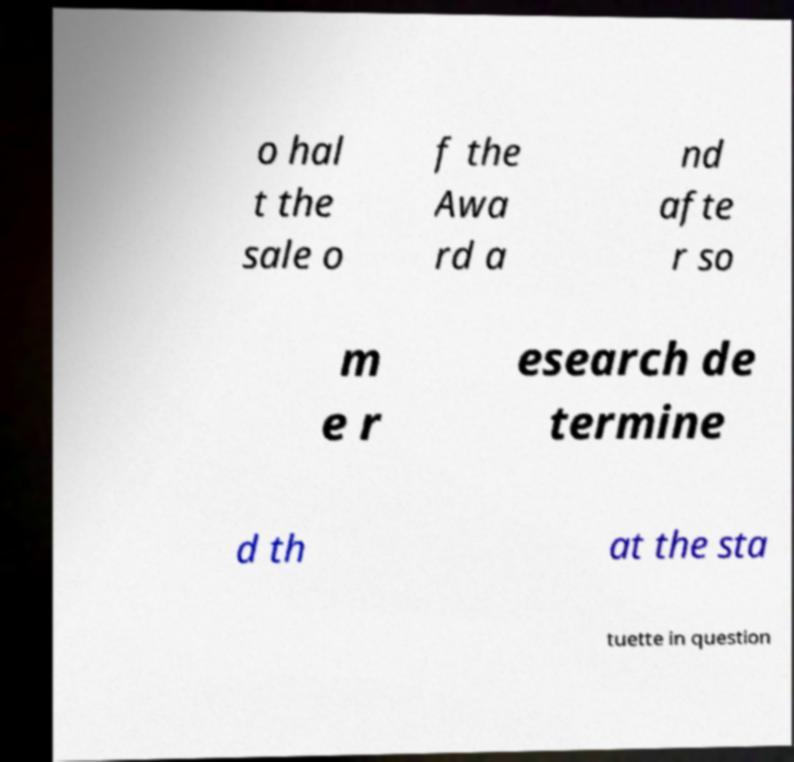Can you accurately transcribe the text from the provided image for me? o hal t the sale o f the Awa rd a nd afte r so m e r esearch de termine d th at the sta tuette in question 